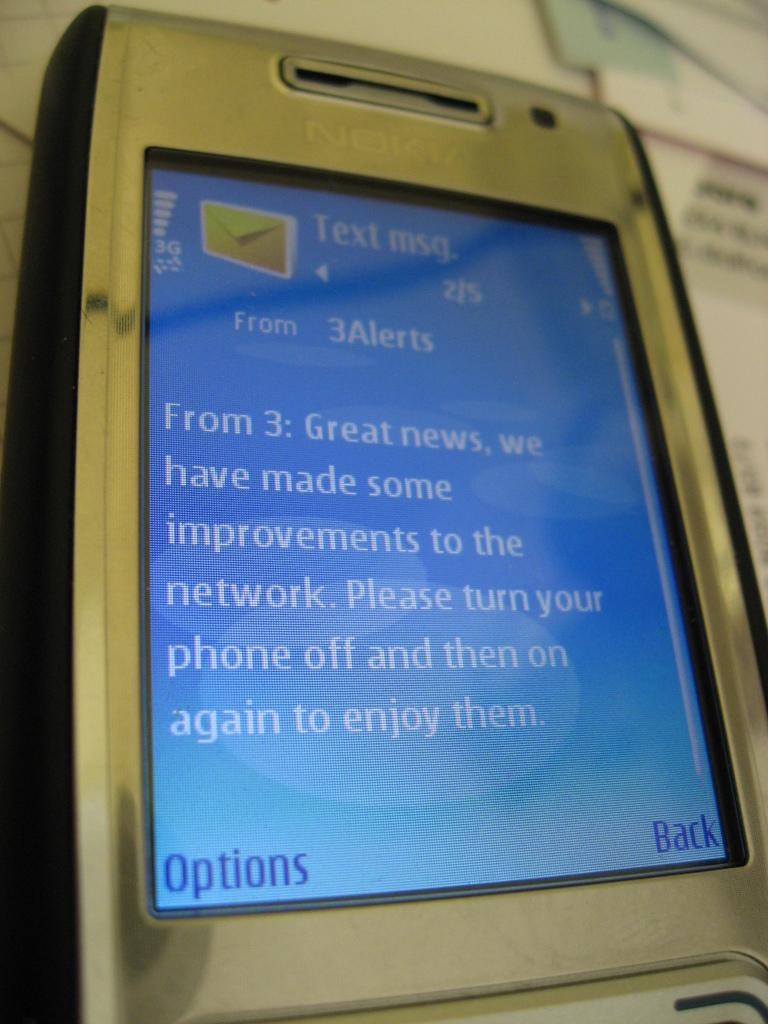<image>
Render a clear and concise summary of the photo. A nokia cellphone displays a text from 3Alerts. 